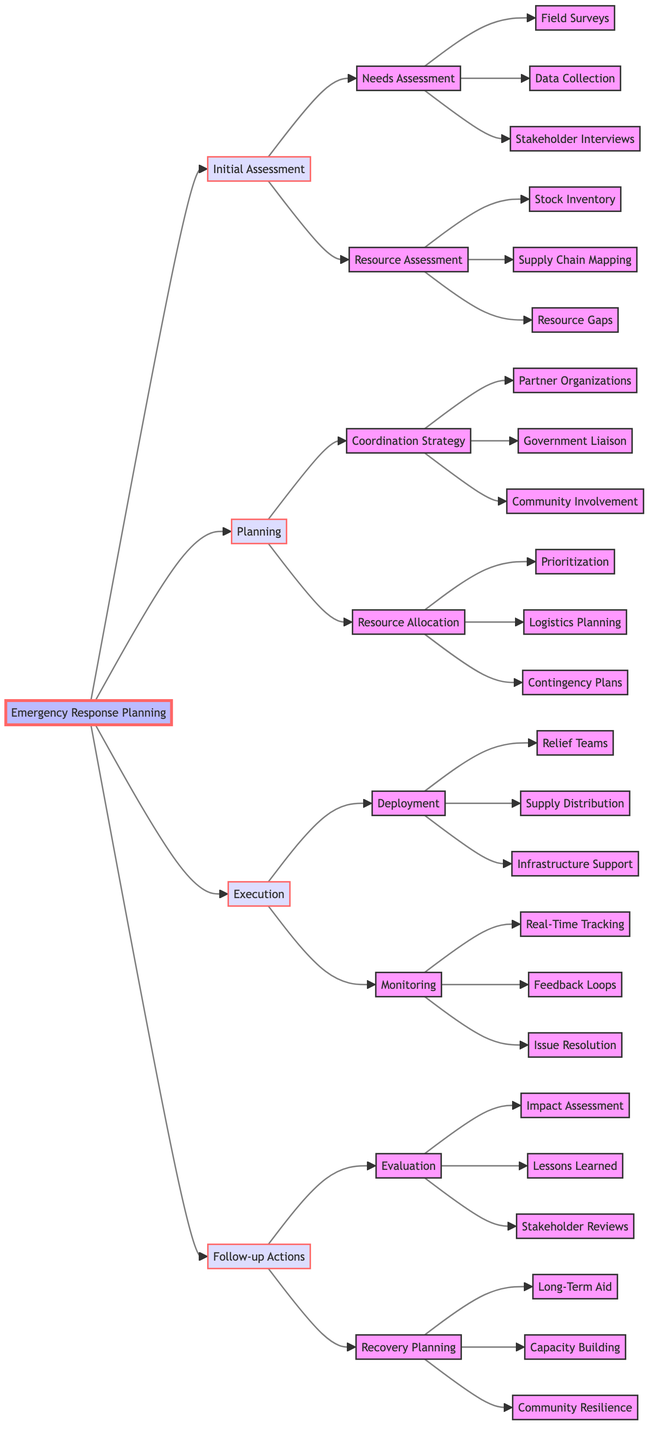What are the main phases of Emergency Response Planning? The diagram directly lists four main phases of Emergency Response Planning: Initial Assessment, Planning, Execution, and Follow-up Actions. These are clearly labeled as the primary categories in the flowchart.
Answer: Initial Assessment, Planning, Execution, Follow-up Actions How many subphases are under Initial Assessment? Under the Initial Assessment phase, there are two subphases: Needs Assessment and Resource Assessment. By counting these categories, we can determine the total number of subphases.
Answer: 2 What action is taken first in the Planning phase? Within the Planning phase, the first action listed is the Coordination Strategy, which encompasses several planning activities to ensure effective response efforts.
Answer: Coordination Strategy What is the last step in the Follow-up Actions? The last action in the Follow-up Actions phase is Community Resilience, which focuses on enhancing local capabilities to withstand future emergencies.
Answer: Community Resilience How does Resource Assessment relate to Needs Assessment? The diagram indicates that both Resource Assessment and Needs Assessment fall under Initial Assessment, showing their relationship as subcategories that help evaluate the situation before proceeding to planning.
Answer: Both are under Initial Assessment Which monitoring action involves community feedback? The feedback loops are specifically mentioned as a monitoring action that incorporates feedback from field teams and affected communities, indicating a mechanism for continuous improvement during execution.
Answer: Feedback Loops What are the three activities under Evaluation in Follow-up Actions? Under the Evaluation step in Follow-up Actions, three activities are listed: Impact Assessment, Lessons Learned, and Stakeholder Reviews. This provides a clear format for gauging effectiveness and gathering input.
Answer: Impact Assessment, Lessons Learned, Stakeholder Reviews How many activities are listed under Deployment? The Deployment action has three listed activities: Relief Teams, Supply Distribution, and Infrastructure Support. By counting them in the flowchart, we arrive at this total.
Answer: 3 What does the Logistics Planning involve? Logistics Planning involves planning for the transportation and distribution of supplies, addressing essentials like routes and delivery schedules, as detailed in the Resource Allocation section.
Answer: Transportation and distribution of supplies 